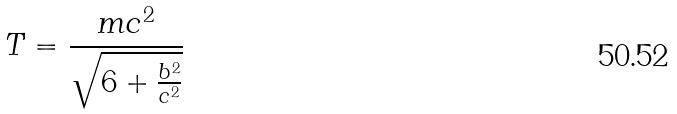Convert formula to latex. <formula><loc_0><loc_0><loc_500><loc_500>T = \frac { m c ^ { 2 } } { \sqrt { 6 + \frac { b ^ { 2 } } { c ^ { 2 } } } }</formula> 